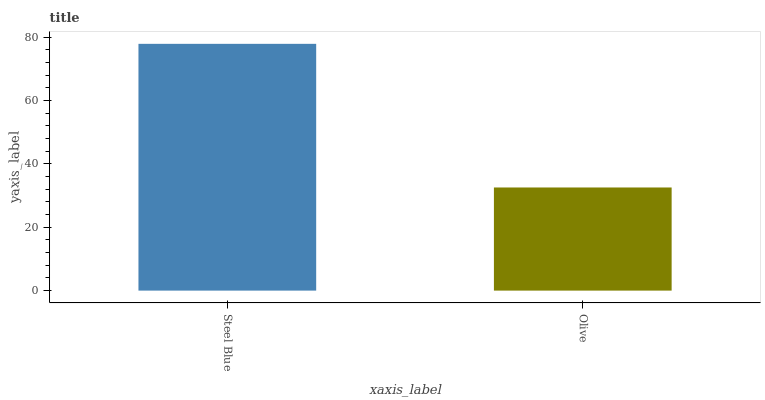Is Steel Blue the maximum?
Answer yes or no. Yes. Is Olive the maximum?
Answer yes or no. No. Is Steel Blue greater than Olive?
Answer yes or no. Yes. Is Olive less than Steel Blue?
Answer yes or no. Yes. Is Olive greater than Steel Blue?
Answer yes or no. No. Is Steel Blue less than Olive?
Answer yes or no. No. Is Steel Blue the high median?
Answer yes or no. Yes. Is Olive the low median?
Answer yes or no. Yes. Is Olive the high median?
Answer yes or no. No. Is Steel Blue the low median?
Answer yes or no. No. 